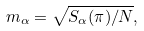Convert formula to latex. <formula><loc_0><loc_0><loc_500><loc_500>m _ { \alpha } = \sqrt { S _ { \alpha } ( \pi ) / N } ,</formula> 